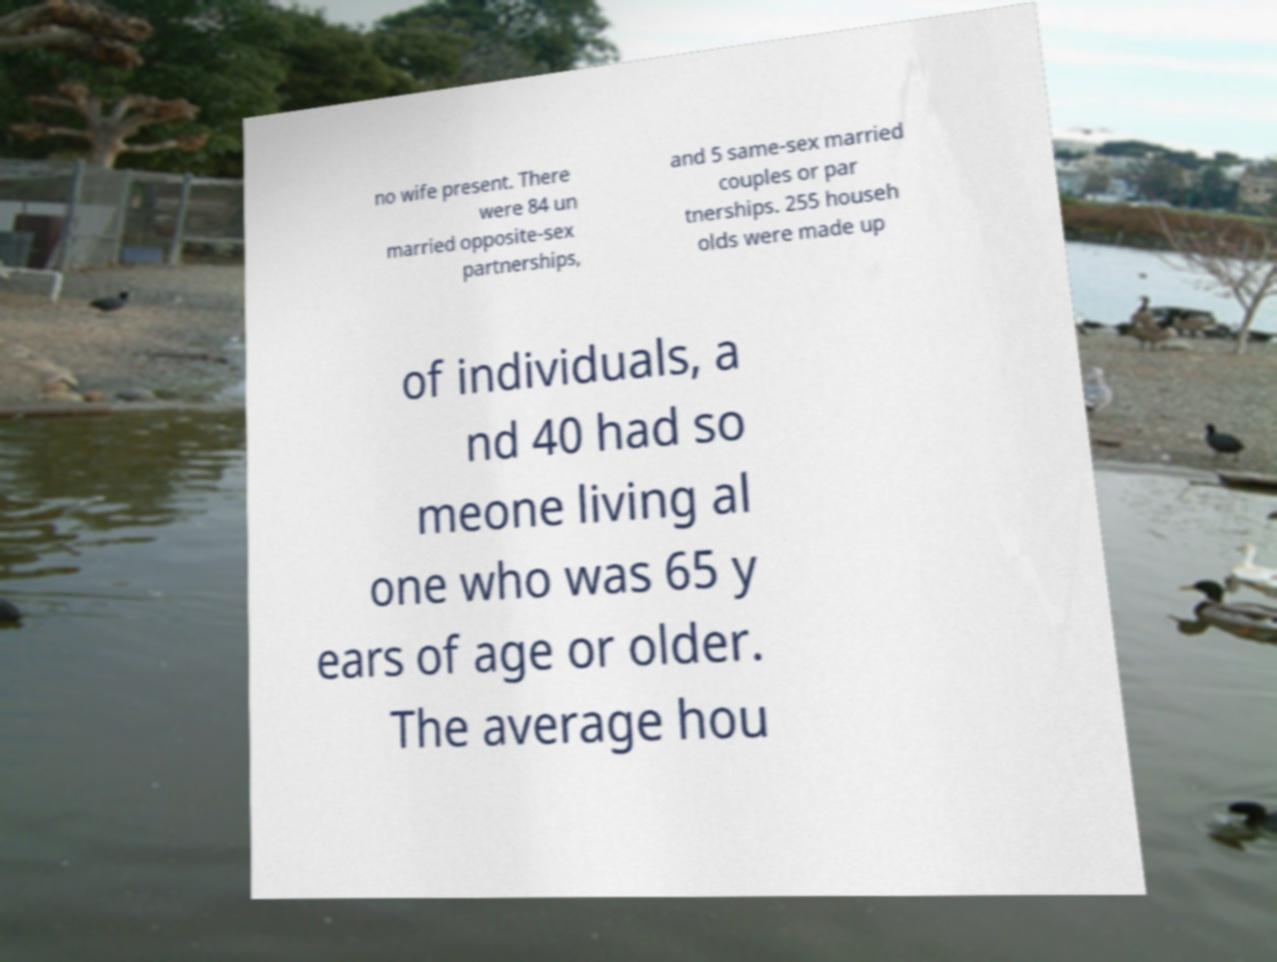Could you extract and type out the text from this image? no wife present. There were 84 un married opposite-sex partnerships, and 5 same-sex married couples or par tnerships. 255 househ olds were made up of individuals, a nd 40 had so meone living al one who was 65 y ears of age or older. The average hou 